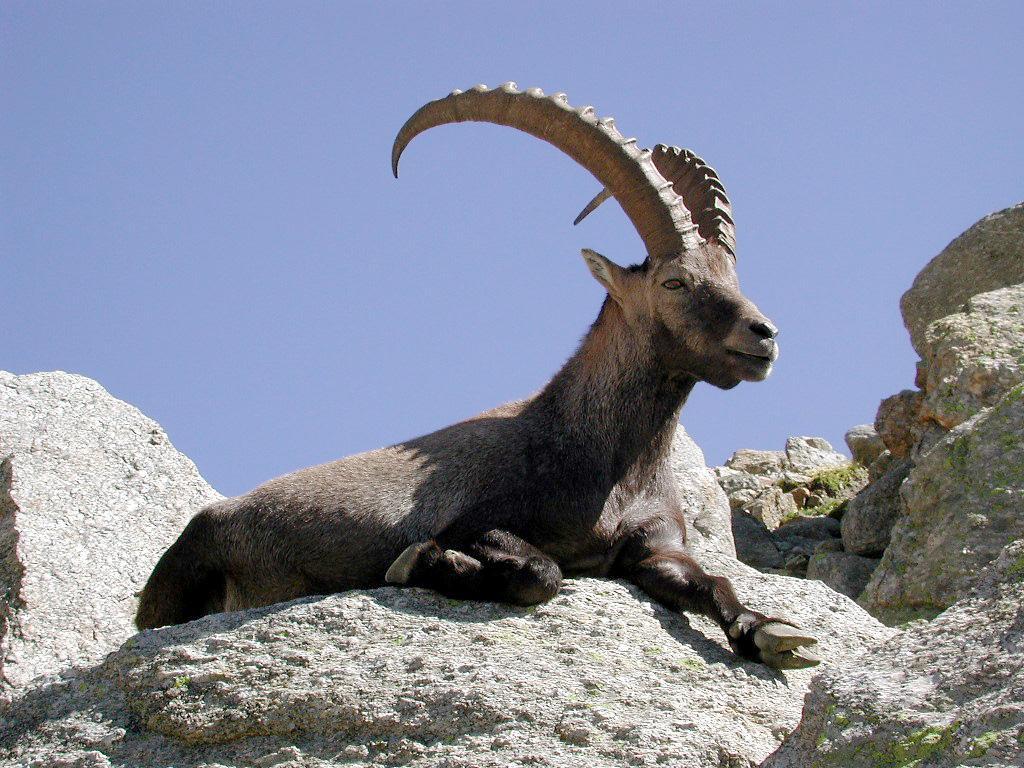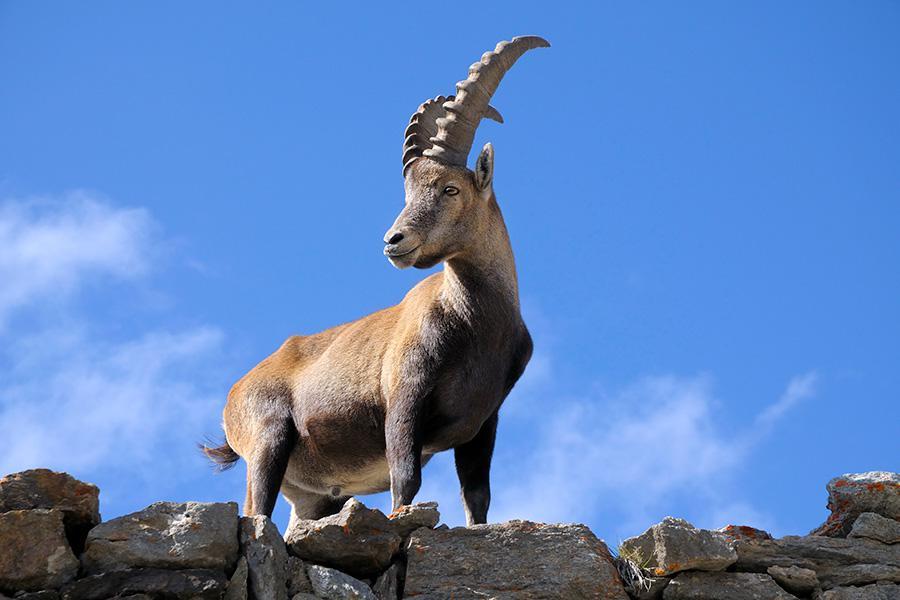The first image is the image on the left, the second image is the image on the right. For the images shown, is this caption "There are 2 goats on the mountain." true? Answer yes or no. Yes. The first image is the image on the left, the second image is the image on the right. Examine the images to the left and right. Is the description "In one image, two animals with large upright horns are perched on a high rocky area." accurate? Answer yes or no. No. 